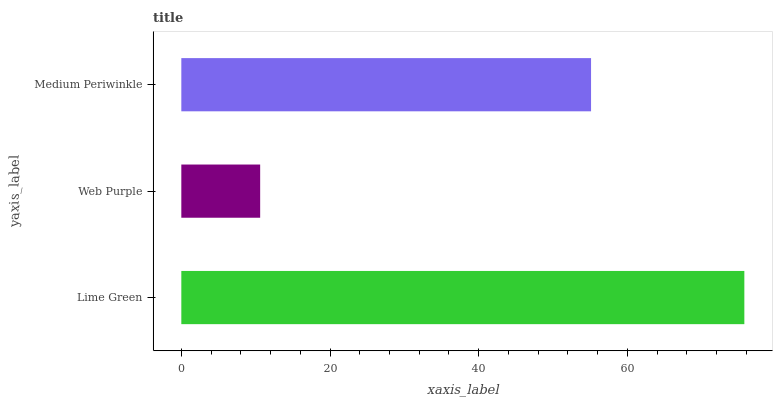Is Web Purple the minimum?
Answer yes or no. Yes. Is Lime Green the maximum?
Answer yes or no. Yes. Is Medium Periwinkle the minimum?
Answer yes or no. No. Is Medium Periwinkle the maximum?
Answer yes or no. No. Is Medium Periwinkle greater than Web Purple?
Answer yes or no. Yes. Is Web Purple less than Medium Periwinkle?
Answer yes or no. Yes. Is Web Purple greater than Medium Periwinkle?
Answer yes or no. No. Is Medium Periwinkle less than Web Purple?
Answer yes or no. No. Is Medium Periwinkle the high median?
Answer yes or no. Yes. Is Medium Periwinkle the low median?
Answer yes or no. Yes. Is Web Purple the high median?
Answer yes or no. No. Is Lime Green the low median?
Answer yes or no. No. 